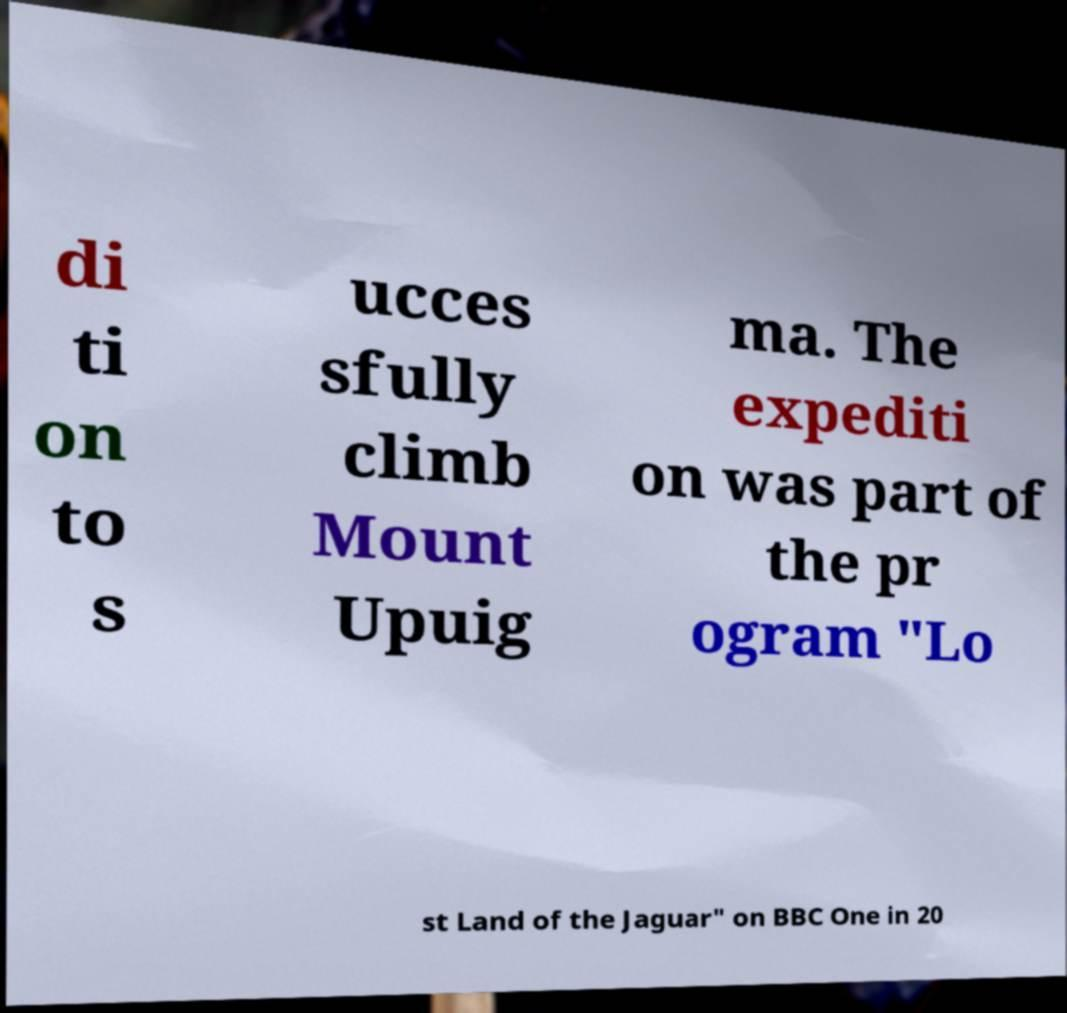What messages or text are displayed in this image? I need them in a readable, typed format. di ti on to s ucces sfully climb Mount Upuig ma. The expediti on was part of the pr ogram "Lo st Land of the Jaguar" on BBC One in 20 